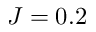<formula> <loc_0><loc_0><loc_500><loc_500>J = 0 . 2</formula> 